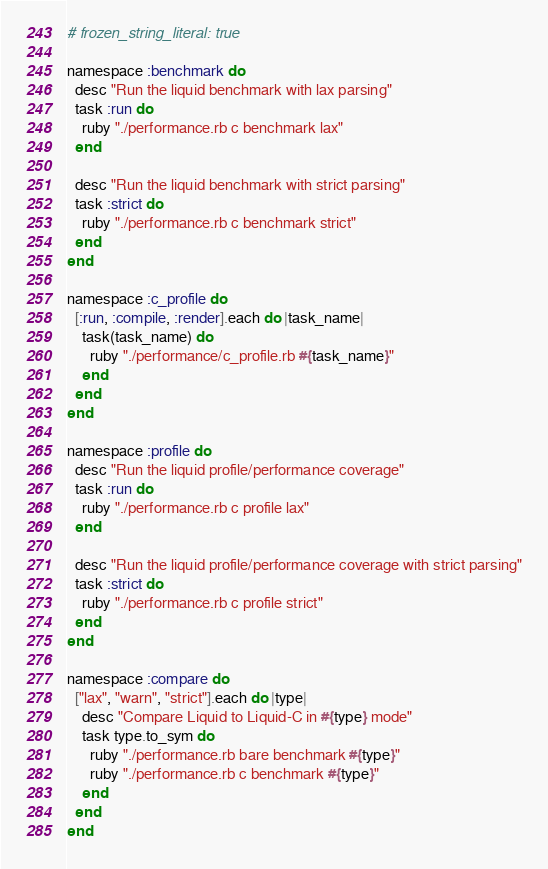<code> <loc_0><loc_0><loc_500><loc_500><_Ruby_># frozen_string_literal: true

namespace :benchmark do
  desc "Run the liquid benchmark with lax parsing"
  task :run do
    ruby "./performance.rb c benchmark lax"
  end

  desc "Run the liquid benchmark with strict parsing"
  task :strict do
    ruby "./performance.rb c benchmark strict"
  end
end

namespace :c_profile do
  [:run, :compile, :render].each do |task_name|
    task(task_name) do
      ruby "./performance/c_profile.rb #{task_name}"
    end
  end
end

namespace :profile do
  desc "Run the liquid profile/performance coverage"
  task :run do
    ruby "./performance.rb c profile lax"
  end

  desc "Run the liquid profile/performance coverage with strict parsing"
  task :strict do
    ruby "./performance.rb c profile strict"
  end
end

namespace :compare do
  ["lax", "warn", "strict"].each do |type|
    desc "Compare Liquid to Liquid-C in #{type} mode"
    task type.to_sym do
      ruby "./performance.rb bare benchmark #{type}"
      ruby "./performance.rb c benchmark #{type}"
    end
  end
end
</code> 